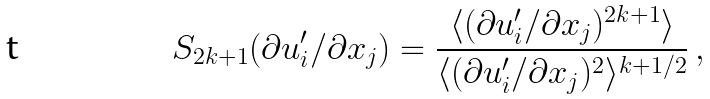Convert formula to latex. <formula><loc_0><loc_0><loc_500><loc_500>S _ { 2 k + 1 } ( \partial u ^ { \prime } _ { i } / \partial x _ { j } ) = \frac { \langle ( \partial u ^ { \prime } _ { i } / \partial x _ { j } ) ^ { 2 k + 1 } \rangle } { \langle ( \partial u ^ { \prime } _ { i } / \partial x _ { j } ) ^ { 2 } \rangle ^ { k + 1 / 2 } } \, ,</formula> 